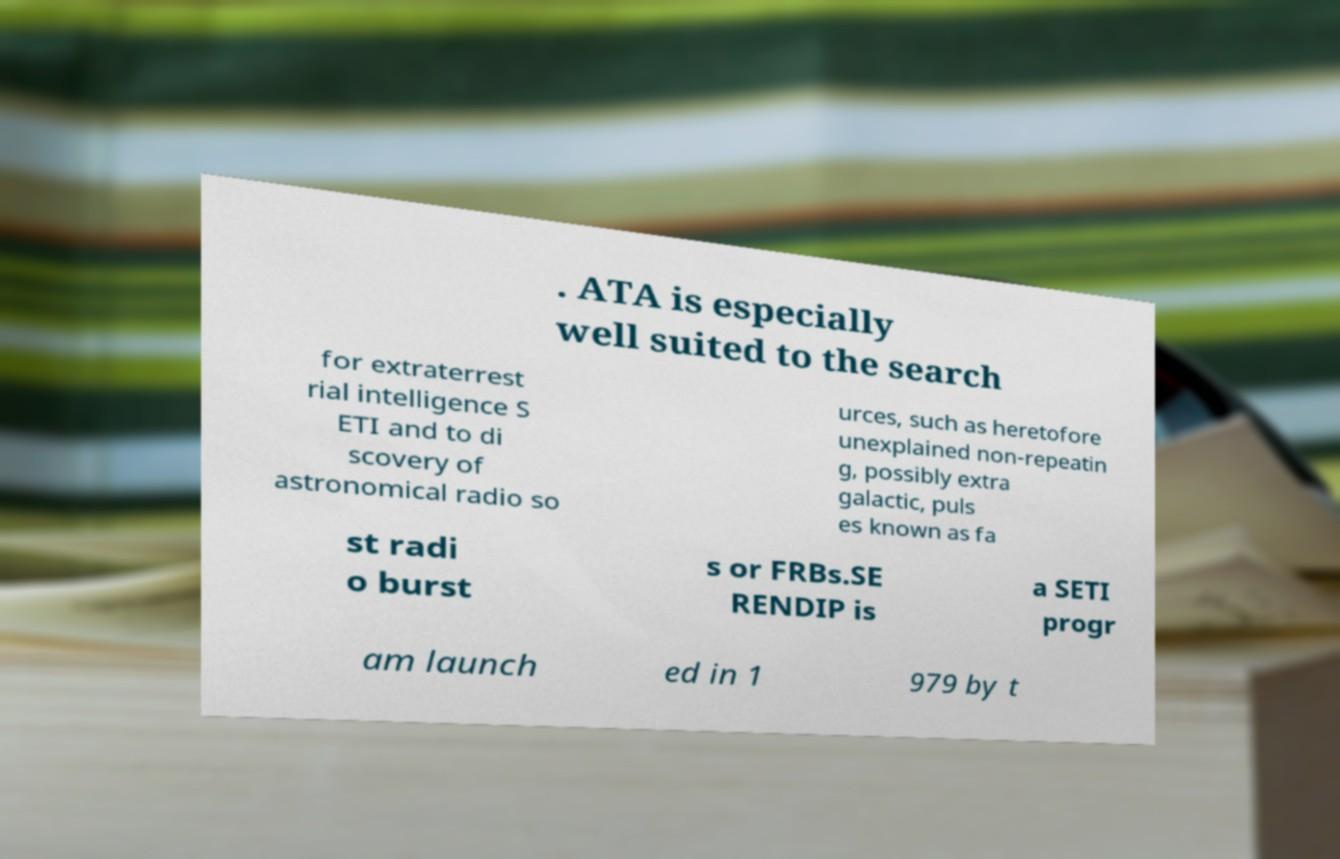Can you read and provide the text displayed in the image?This photo seems to have some interesting text. Can you extract and type it out for me? . ATA is especially well suited to the search for extraterrest rial intelligence S ETI and to di scovery of astronomical radio so urces, such as heretofore unexplained non-repeatin g, possibly extra galactic, puls es known as fa st radi o burst s or FRBs.SE RENDIP is a SETI progr am launch ed in 1 979 by t 